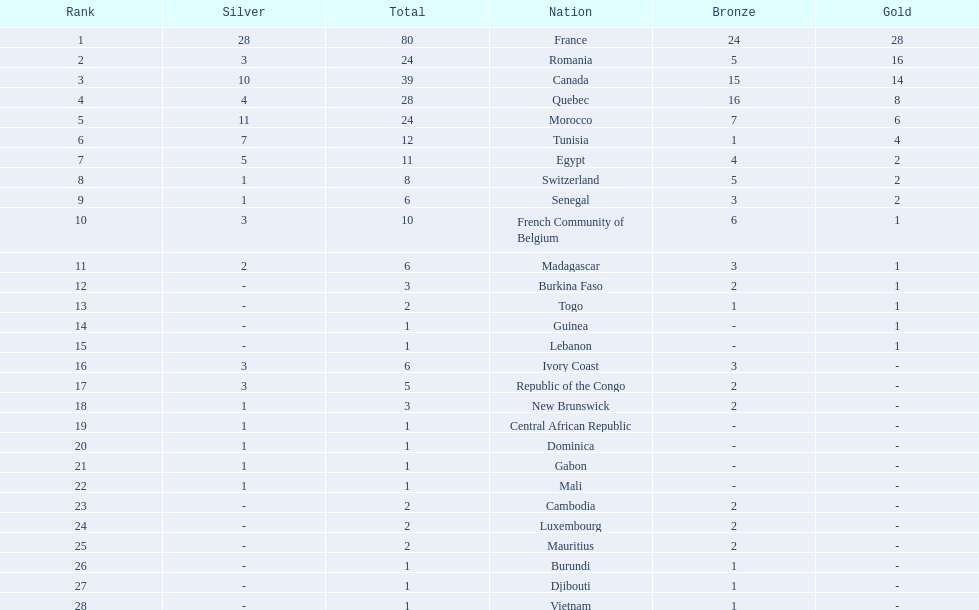How many nations won at least 10 medals? 8. 